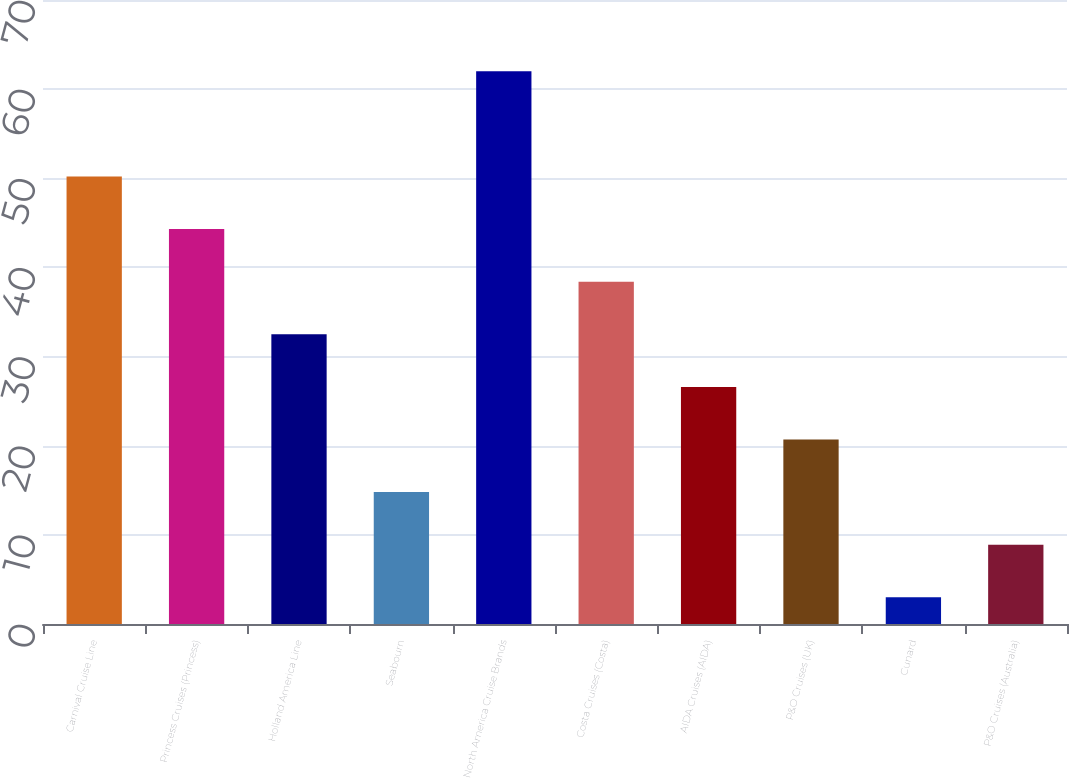Convert chart to OTSL. <chart><loc_0><loc_0><loc_500><loc_500><bar_chart><fcel>Carnival Cruise Line<fcel>Princess Cruises (Princess)<fcel>Holland America Line<fcel>Seabourn<fcel>North America Cruise Brands<fcel>Costa Cruises (Costa)<fcel>AIDA Cruises (AIDA)<fcel>P&O Cruises (UK)<fcel>Cunard<fcel>P&O Cruises (Australia)<nl><fcel>50.2<fcel>44.3<fcel>32.5<fcel>14.8<fcel>62<fcel>38.4<fcel>26.6<fcel>20.7<fcel>3<fcel>8.9<nl></chart> 